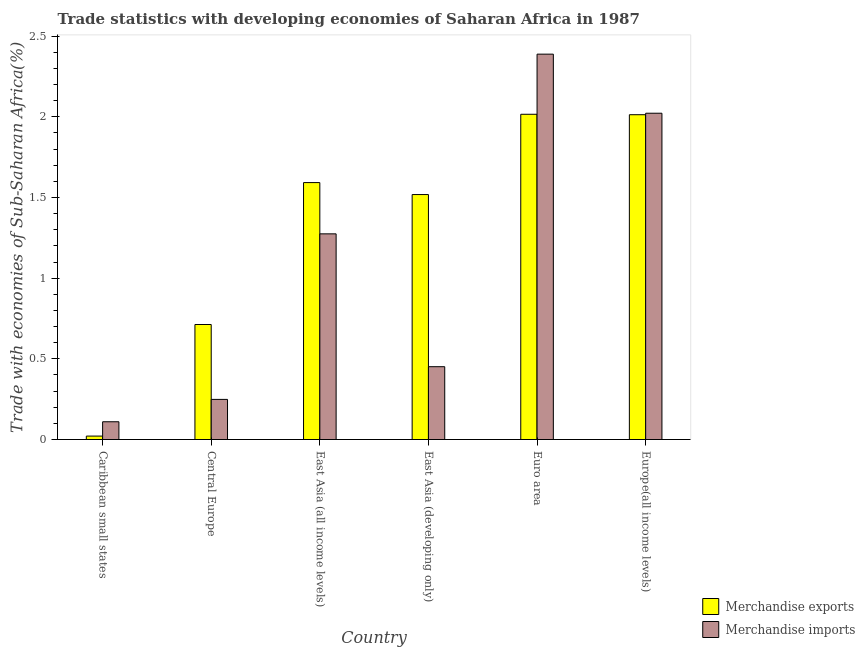How many different coloured bars are there?
Make the answer very short. 2. Are the number of bars on each tick of the X-axis equal?
Provide a short and direct response. Yes. How many bars are there on the 3rd tick from the left?
Keep it short and to the point. 2. How many bars are there on the 4th tick from the right?
Make the answer very short. 2. What is the merchandise imports in East Asia (developing only)?
Ensure brevity in your answer.  0.45. Across all countries, what is the maximum merchandise imports?
Your response must be concise. 2.39. Across all countries, what is the minimum merchandise exports?
Give a very brief answer. 0.02. In which country was the merchandise imports minimum?
Your response must be concise. Caribbean small states. What is the total merchandise imports in the graph?
Your answer should be compact. 6.5. What is the difference between the merchandise imports in Central Europe and that in East Asia (all income levels)?
Offer a terse response. -1.03. What is the difference between the merchandise exports in Europe(all income levels) and the merchandise imports in Caribbean small states?
Keep it short and to the point. 1.9. What is the average merchandise exports per country?
Keep it short and to the point. 1.31. What is the difference between the merchandise exports and merchandise imports in East Asia (all income levels)?
Make the answer very short. 0.32. In how many countries, is the merchandise imports greater than 0.5 %?
Offer a terse response. 3. What is the ratio of the merchandise imports in Caribbean small states to that in Euro area?
Your answer should be very brief. 0.05. What is the difference between the highest and the second highest merchandise exports?
Offer a terse response. 0. What is the difference between the highest and the lowest merchandise imports?
Provide a short and direct response. 2.28. In how many countries, is the merchandise imports greater than the average merchandise imports taken over all countries?
Your answer should be compact. 3. What does the 2nd bar from the left in Euro area represents?
Provide a short and direct response. Merchandise imports. Are all the bars in the graph horizontal?
Ensure brevity in your answer.  No. How many countries are there in the graph?
Provide a succinct answer. 6. What is the difference between two consecutive major ticks on the Y-axis?
Your response must be concise. 0.5. Does the graph contain any zero values?
Give a very brief answer. No. Where does the legend appear in the graph?
Provide a succinct answer. Bottom right. How many legend labels are there?
Provide a short and direct response. 2. How are the legend labels stacked?
Offer a terse response. Vertical. What is the title of the graph?
Provide a succinct answer. Trade statistics with developing economies of Saharan Africa in 1987. Does "Borrowers" appear as one of the legend labels in the graph?
Give a very brief answer. No. What is the label or title of the Y-axis?
Offer a terse response. Trade with economies of Sub-Saharan Africa(%). What is the Trade with economies of Sub-Saharan Africa(%) in Merchandise exports in Caribbean small states?
Provide a succinct answer. 0.02. What is the Trade with economies of Sub-Saharan Africa(%) in Merchandise imports in Caribbean small states?
Ensure brevity in your answer.  0.11. What is the Trade with economies of Sub-Saharan Africa(%) of Merchandise exports in Central Europe?
Your answer should be very brief. 0.71. What is the Trade with economies of Sub-Saharan Africa(%) in Merchandise imports in Central Europe?
Make the answer very short. 0.25. What is the Trade with economies of Sub-Saharan Africa(%) in Merchandise exports in East Asia (all income levels)?
Your response must be concise. 1.59. What is the Trade with economies of Sub-Saharan Africa(%) in Merchandise imports in East Asia (all income levels)?
Keep it short and to the point. 1.27. What is the Trade with economies of Sub-Saharan Africa(%) of Merchandise exports in East Asia (developing only)?
Your response must be concise. 1.52. What is the Trade with economies of Sub-Saharan Africa(%) in Merchandise imports in East Asia (developing only)?
Give a very brief answer. 0.45. What is the Trade with economies of Sub-Saharan Africa(%) in Merchandise exports in Euro area?
Keep it short and to the point. 2.02. What is the Trade with economies of Sub-Saharan Africa(%) in Merchandise imports in Euro area?
Provide a succinct answer. 2.39. What is the Trade with economies of Sub-Saharan Africa(%) in Merchandise exports in Europe(all income levels)?
Your response must be concise. 2.01. What is the Trade with economies of Sub-Saharan Africa(%) of Merchandise imports in Europe(all income levels)?
Your response must be concise. 2.02. Across all countries, what is the maximum Trade with economies of Sub-Saharan Africa(%) in Merchandise exports?
Offer a terse response. 2.02. Across all countries, what is the maximum Trade with economies of Sub-Saharan Africa(%) in Merchandise imports?
Ensure brevity in your answer.  2.39. Across all countries, what is the minimum Trade with economies of Sub-Saharan Africa(%) of Merchandise exports?
Keep it short and to the point. 0.02. Across all countries, what is the minimum Trade with economies of Sub-Saharan Africa(%) in Merchandise imports?
Ensure brevity in your answer.  0.11. What is the total Trade with economies of Sub-Saharan Africa(%) of Merchandise exports in the graph?
Ensure brevity in your answer.  7.87. What is the total Trade with economies of Sub-Saharan Africa(%) of Merchandise imports in the graph?
Make the answer very short. 6.5. What is the difference between the Trade with economies of Sub-Saharan Africa(%) of Merchandise exports in Caribbean small states and that in Central Europe?
Your response must be concise. -0.69. What is the difference between the Trade with economies of Sub-Saharan Africa(%) of Merchandise imports in Caribbean small states and that in Central Europe?
Your answer should be very brief. -0.14. What is the difference between the Trade with economies of Sub-Saharan Africa(%) in Merchandise exports in Caribbean small states and that in East Asia (all income levels)?
Offer a terse response. -1.57. What is the difference between the Trade with economies of Sub-Saharan Africa(%) in Merchandise imports in Caribbean small states and that in East Asia (all income levels)?
Ensure brevity in your answer.  -1.16. What is the difference between the Trade with economies of Sub-Saharan Africa(%) of Merchandise exports in Caribbean small states and that in East Asia (developing only)?
Provide a succinct answer. -1.5. What is the difference between the Trade with economies of Sub-Saharan Africa(%) in Merchandise imports in Caribbean small states and that in East Asia (developing only)?
Your answer should be compact. -0.34. What is the difference between the Trade with economies of Sub-Saharan Africa(%) in Merchandise exports in Caribbean small states and that in Euro area?
Keep it short and to the point. -1.99. What is the difference between the Trade with economies of Sub-Saharan Africa(%) of Merchandise imports in Caribbean small states and that in Euro area?
Give a very brief answer. -2.28. What is the difference between the Trade with economies of Sub-Saharan Africa(%) of Merchandise exports in Caribbean small states and that in Europe(all income levels)?
Your answer should be very brief. -1.99. What is the difference between the Trade with economies of Sub-Saharan Africa(%) in Merchandise imports in Caribbean small states and that in Europe(all income levels)?
Make the answer very short. -1.91. What is the difference between the Trade with economies of Sub-Saharan Africa(%) of Merchandise exports in Central Europe and that in East Asia (all income levels)?
Provide a succinct answer. -0.88. What is the difference between the Trade with economies of Sub-Saharan Africa(%) of Merchandise imports in Central Europe and that in East Asia (all income levels)?
Provide a succinct answer. -1.03. What is the difference between the Trade with economies of Sub-Saharan Africa(%) in Merchandise exports in Central Europe and that in East Asia (developing only)?
Offer a terse response. -0.81. What is the difference between the Trade with economies of Sub-Saharan Africa(%) in Merchandise imports in Central Europe and that in East Asia (developing only)?
Offer a very short reply. -0.2. What is the difference between the Trade with economies of Sub-Saharan Africa(%) in Merchandise exports in Central Europe and that in Euro area?
Keep it short and to the point. -1.3. What is the difference between the Trade with economies of Sub-Saharan Africa(%) in Merchandise imports in Central Europe and that in Euro area?
Provide a succinct answer. -2.14. What is the difference between the Trade with economies of Sub-Saharan Africa(%) in Merchandise exports in Central Europe and that in Europe(all income levels)?
Ensure brevity in your answer.  -1.3. What is the difference between the Trade with economies of Sub-Saharan Africa(%) in Merchandise imports in Central Europe and that in Europe(all income levels)?
Make the answer very short. -1.77. What is the difference between the Trade with economies of Sub-Saharan Africa(%) in Merchandise exports in East Asia (all income levels) and that in East Asia (developing only)?
Give a very brief answer. 0.07. What is the difference between the Trade with economies of Sub-Saharan Africa(%) in Merchandise imports in East Asia (all income levels) and that in East Asia (developing only)?
Your response must be concise. 0.82. What is the difference between the Trade with economies of Sub-Saharan Africa(%) in Merchandise exports in East Asia (all income levels) and that in Euro area?
Provide a short and direct response. -0.42. What is the difference between the Trade with economies of Sub-Saharan Africa(%) in Merchandise imports in East Asia (all income levels) and that in Euro area?
Make the answer very short. -1.11. What is the difference between the Trade with economies of Sub-Saharan Africa(%) of Merchandise exports in East Asia (all income levels) and that in Europe(all income levels)?
Your answer should be very brief. -0.42. What is the difference between the Trade with economies of Sub-Saharan Africa(%) in Merchandise imports in East Asia (all income levels) and that in Europe(all income levels)?
Your answer should be compact. -0.75. What is the difference between the Trade with economies of Sub-Saharan Africa(%) of Merchandise exports in East Asia (developing only) and that in Euro area?
Offer a very short reply. -0.5. What is the difference between the Trade with economies of Sub-Saharan Africa(%) of Merchandise imports in East Asia (developing only) and that in Euro area?
Give a very brief answer. -1.94. What is the difference between the Trade with economies of Sub-Saharan Africa(%) in Merchandise exports in East Asia (developing only) and that in Europe(all income levels)?
Ensure brevity in your answer.  -0.49. What is the difference between the Trade with economies of Sub-Saharan Africa(%) of Merchandise imports in East Asia (developing only) and that in Europe(all income levels)?
Ensure brevity in your answer.  -1.57. What is the difference between the Trade with economies of Sub-Saharan Africa(%) in Merchandise exports in Euro area and that in Europe(all income levels)?
Your answer should be compact. 0. What is the difference between the Trade with economies of Sub-Saharan Africa(%) in Merchandise imports in Euro area and that in Europe(all income levels)?
Offer a very short reply. 0.37. What is the difference between the Trade with economies of Sub-Saharan Africa(%) in Merchandise exports in Caribbean small states and the Trade with economies of Sub-Saharan Africa(%) in Merchandise imports in Central Europe?
Your answer should be compact. -0.23. What is the difference between the Trade with economies of Sub-Saharan Africa(%) of Merchandise exports in Caribbean small states and the Trade with economies of Sub-Saharan Africa(%) of Merchandise imports in East Asia (all income levels)?
Your answer should be compact. -1.25. What is the difference between the Trade with economies of Sub-Saharan Africa(%) of Merchandise exports in Caribbean small states and the Trade with economies of Sub-Saharan Africa(%) of Merchandise imports in East Asia (developing only)?
Provide a short and direct response. -0.43. What is the difference between the Trade with economies of Sub-Saharan Africa(%) of Merchandise exports in Caribbean small states and the Trade with economies of Sub-Saharan Africa(%) of Merchandise imports in Euro area?
Provide a succinct answer. -2.37. What is the difference between the Trade with economies of Sub-Saharan Africa(%) in Merchandise exports in Caribbean small states and the Trade with economies of Sub-Saharan Africa(%) in Merchandise imports in Europe(all income levels)?
Provide a short and direct response. -2. What is the difference between the Trade with economies of Sub-Saharan Africa(%) in Merchandise exports in Central Europe and the Trade with economies of Sub-Saharan Africa(%) in Merchandise imports in East Asia (all income levels)?
Make the answer very short. -0.56. What is the difference between the Trade with economies of Sub-Saharan Africa(%) in Merchandise exports in Central Europe and the Trade with economies of Sub-Saharan Africa(%) in Merchandise imports in East Asia (developing only)?
Make the answer very short. 0.26. What is the difference between the Trade with economies of Sub-Saharan Africa(%) in Merchandise exports in Central Europe and the Trade with economies of Sub-Saharan Africa(%) in Merchandise imports in Euro area?
Make the answer very short. -1.68. What is the difference between the Trade with economies of Sub-Saharan Africa(%) of Merchandise exports in Central Europe and the Trade with economies of Sub-Saharan Africa(%) of Merchandise imports in Europe(all income levels)?
Provide a succinct answer. -1.31. What is the difference between the Trade with economies of Sub-Saharan Africa(%) of Merchandise exports in East Asia (all income levels) and the Trade with economies of Sub-Saharan Africa(%) of Merchandise imports in East Asia (developing only)?
Your answer should be compact. 1.14. What is the difference between the Trade with economies of Sub-Saharan Africa(%) in Merchandise exports in East Asia (all income levels) and the Trade with economies of Sub-Saharan Africa(%) in Merchandise imports in Euro area?
Provide a succinct answer. -0.8. What is the difference between the Trade with economies of Sub-Saharan Africa(%) in Merchandise exports in East Asia (all income levels) and the Trade with economies of Sub-Saharan Africa(%) in Merchandise imports in Europe(all income levels)?
Your answer should be compact. -0.43. What is the difference between the Trade with economies of Sub-Saharan Africa(%) of Merchandise exports in East Asia (developing only) and the Trade with economies of Sub-Saharan Africa(%) of Merchandise imports in Euro area?
Your answer should be compact. -0.87. What is the difference between the Trade with economies of Sub-Saharan Africa(%) of Merchandise exports in East Asia (developing only) and the Trade with economies of Sub-Saharan Africa(%) of Merchandise imports in Europe(all income levels)?
Your answer should be compact. -0.5. What is the difference between the Trade with economies of Sub-Saharan Africa(%) in Merchandise exports in Euro area and the Trade with economies of Sub-Saharan Africa(%) in Merchandise imports in Europe(all income levels)?
Offer a terse response. -0.01. What is the average Trade with economies of Sub-Saharan Africa(%) in Merchandise exports per country?
Offer a terse response. 1.31. What is the average Trade with economies of Sub-Saharan Africa(%) of Merchandise imports per country?
Provide a short and direct response. 1.08. What is the difference between the Trade with economies of Sub-Saharan Africa(%) in Merchandise exports and Trade with economies of Sub-Saharan Africa(%) in Merchandise imports in Caribbean small states?
Offer a terse response. -0.09. What is the difference between the Trade with economies of Sub-Saharan Africa(%) of Merchandise exports and Trade with economies of Sub-Saharan Africa(%) of Merchandise imports in Central Europe?
Ensure brevity in your answer.  0.46. What is the difference between the Trade with economies of Sub-Saharan Africa(%) in Merchandise exports and Trade with economies of Sub-Saharan Africa(%) in Merchandise imports in East Asia (all income levels)?
Your answer should be very brief. 0.32. What is the difference between the Trade with economies of Sub-Saharan Africa(%) of Merchandise exports and Trade with economies of Sub-Saharan Africa(%) of Merchandise imports in East Asia (developing only)?
Provide a short and direct response. 1.07. What is the difference between the Trade with economies of Sub-Saharan Africa(%) in Merchandise exports and Trade with economies of Sub-Saharan Africa(%) in Merchandise imports in Euro area?
Give a very brief answer. -0.37. What is the difference between the Trade with economies of Sub-Saharan Africa(%) in Merchandise exports and Trade with economies of Sub-Saharan Africa(%) in Merchandise imports in Europe(all income levels)?
Your answer should be very brief. -0.01. What is the ratio of the Trade with economies of Sub-Saharan Africa(%) of Merchandise exports in Caribbean small states to that in Central Europe?
Keep it short and to the point. 0.03. What is the ratio of the Trade with economies of Sub-Saharan Africa(%) in Merchandise imports in Caribbean small states to that in Central Europe?
Offer a terse response. 0.44. What is the ratio of the Trade with economies of Sub-Saharan Africa(%) in Merchandise exports in Caribbean small states to that in East Asia (all income levels)?
Your answer should be very brief. 0.01. What is the ratio of the Trade with economies of Sub-Saharan Africa(%) in Merchandise imports in Caribbean small states to that in East Asia (all income levels)?
Your answer should be very brief. 0.09. What is the ratio of the Trade with economies of Sub-Saharan Africa(%) of Merchandise exports in Caribbean small states to that in East Asia (developing only)?
Your response must be concise. 0.01. What is the ratio of the Trade with economies of Sub-Saharan Africa(%) in Merchandise imports in Caribbean small states to that in East Asia (developing only)?
Make the answer very short. 0.24. What is the ratio of the Trade with economies of Sub-Saharan Africa(%) in Merchandise exports in Caribbean small states to that in Euro area?
Ensure brevity in your answer.  0.01. What is the ratio of the Trade with economies of Sub-Saharan Africa(%) of Merchandise imports in Caribbean small states to that in Euro area?
Make the answer very short. 0.05. What is the ratio of the Trade with economies of Sub-Saharan Africa(%) of Merchandise exports in Caribbean small states to that in Europe(all income levels)?
Your answer should be very brief. 0.01. What is the ratio of the Trade with economies of Sub-Saharan Africa(%) in Merchandise imports in Caribbean small states to that in Europe(all income levels)?
Provide a short and direct response. 0.05. What is the ratio of the Trade with economies of Sub-Saharan Africa(%) in Merchandise exports in Central Europe to that in East Asia (all income levels)?
Ensure brevity in your answer.  0.45. What is the ratio of the Trade with economies of Sub-Saharan Africa(%) in Merchandise imports in Central Europe to that in East Asia (all income levels)?
Give a very brief answer. 0.2. What is the ratio of the Trade with economies of Sub-Saharan Africa(%) in Merchandise exports in Central Europe to that in East Asia (developing only)?
Keep it short and to the point. 0.47. What is the ratio of the Trade with economies of Sub-Saharan Africa(%) of Merchandise imports in Central Europe to that in East Asia (developing only)?
Your response must be concise. 0.55. What is the ratio of the Trade with economies of Sub-Saharan Africa(%) in Merchandise exports in Central Europe to that in Euro area?
Your answer should be compact. 0.35. What is the ratio of the Trade with economies of Sub-Saharan Africa(%) in Merchandise imports in Central Europe to that in Euro area?
Offer a terse response. 0.1. What is the ratio of the Trade with economies of Sub-Saharan Africa(%) of Merchandise exports in Central Europe to that in Europe(all income levels)?
Keep it short and to the point. 0.35. What is the ratio of the Trade with economies of Sub-Saharan Africa(%) of Merchandise imports in Central Europe to that in Europe(all income levels)?
Offer a very short reply. 0.12. What is the ratio of the Trade with economies of Sub-Saharan Africa(%) in Merchandise exports in East Asia (all income levels) to that in East Asia (developing only)?
Make the answer very short. 1.05. What is the ratio of the Trade with economies of Sub-Saharan Africa(%) in Merchandise imports in East Asia (all income levels) to that in East Asia (developing only)?
Keep it short and to the point. 2.82. What is the ratio of the Trade with economies of Sub-Saharan Africa(%) in Merchandise exports in East Asia (all income levels) to that in Euro area?
Keep it short and to the point. 0.79. What is the ratio of the Trade with economies of Sub-Saharan Africa(%) of Merchandise imports in East Asia (all income levels) to that in Euro area?
Ensure brevity in your answer.  0.53. What is the ratio of the Trade with economies of Sub-Saharan Africa(%) of Merchandise exports in East Asia (all income levels) to that in Europe(all income levels)?
Give a very brief answer. 0.79. What is the ratio of the Trade with economies of Sub-Saharan Africa(%) in Merchandise imports in East Asia (all income levels) to that in Europe(all income levels)?
Keep it short and to the point. 0.63. What is the ratio of the Trade with economies of Sub-Saharan Africa(%) in Merchandise exports in East Asia (developing only) to that in Euro area?
Offer a very short reply. 0.75. What is the ratio of the Trade with economies of Sub-Saharan Africa(%) of Merchandise imports in East Asia (developing only) to that in Euro area?
Your answer should be very brief. 0.19. What is the ratio of the Trade with economies of Sub-Saharan Africa(%) of Merchandise exports in East Asia (developing only) to that in Europe(all income levels)?
Your answer should be very brief. 0.75. What is the ratio of the Trade with economies of Sub-Saharan Africa(%) of Merchandise imports in East Asia (developing only) to that in Europe(all income levels)?
Make the answer very short. 0.22. What is the ratio of the Trade with economies of Sub-Saharan Africa(%) in Merchandise imports in Euro area to that in Europe(all income levels)?
Your answer should be very brief. 1.18. What is the difference between the highest and the second highest Trade with economies of Sub-Saharan Africa(%) of Merchandise exports?
Offer a terse response. 0. What is the difference between the highest and the second highest Trade with economies of Sub-Saharan Africa(%) in Merchandise imports?
Your response must be concise. 0.37. What is the difference between the highest and the lowest Trade with economies of Sub-Saharan Africa(%) of Merchandise exports?
Give a very brief answer. 1.99. What is the difference between the highest and the lowest Trade with economies of Sub-Saharan Africa(%) in Merchandise imports?
Your answer should be very brief. 2.28. 